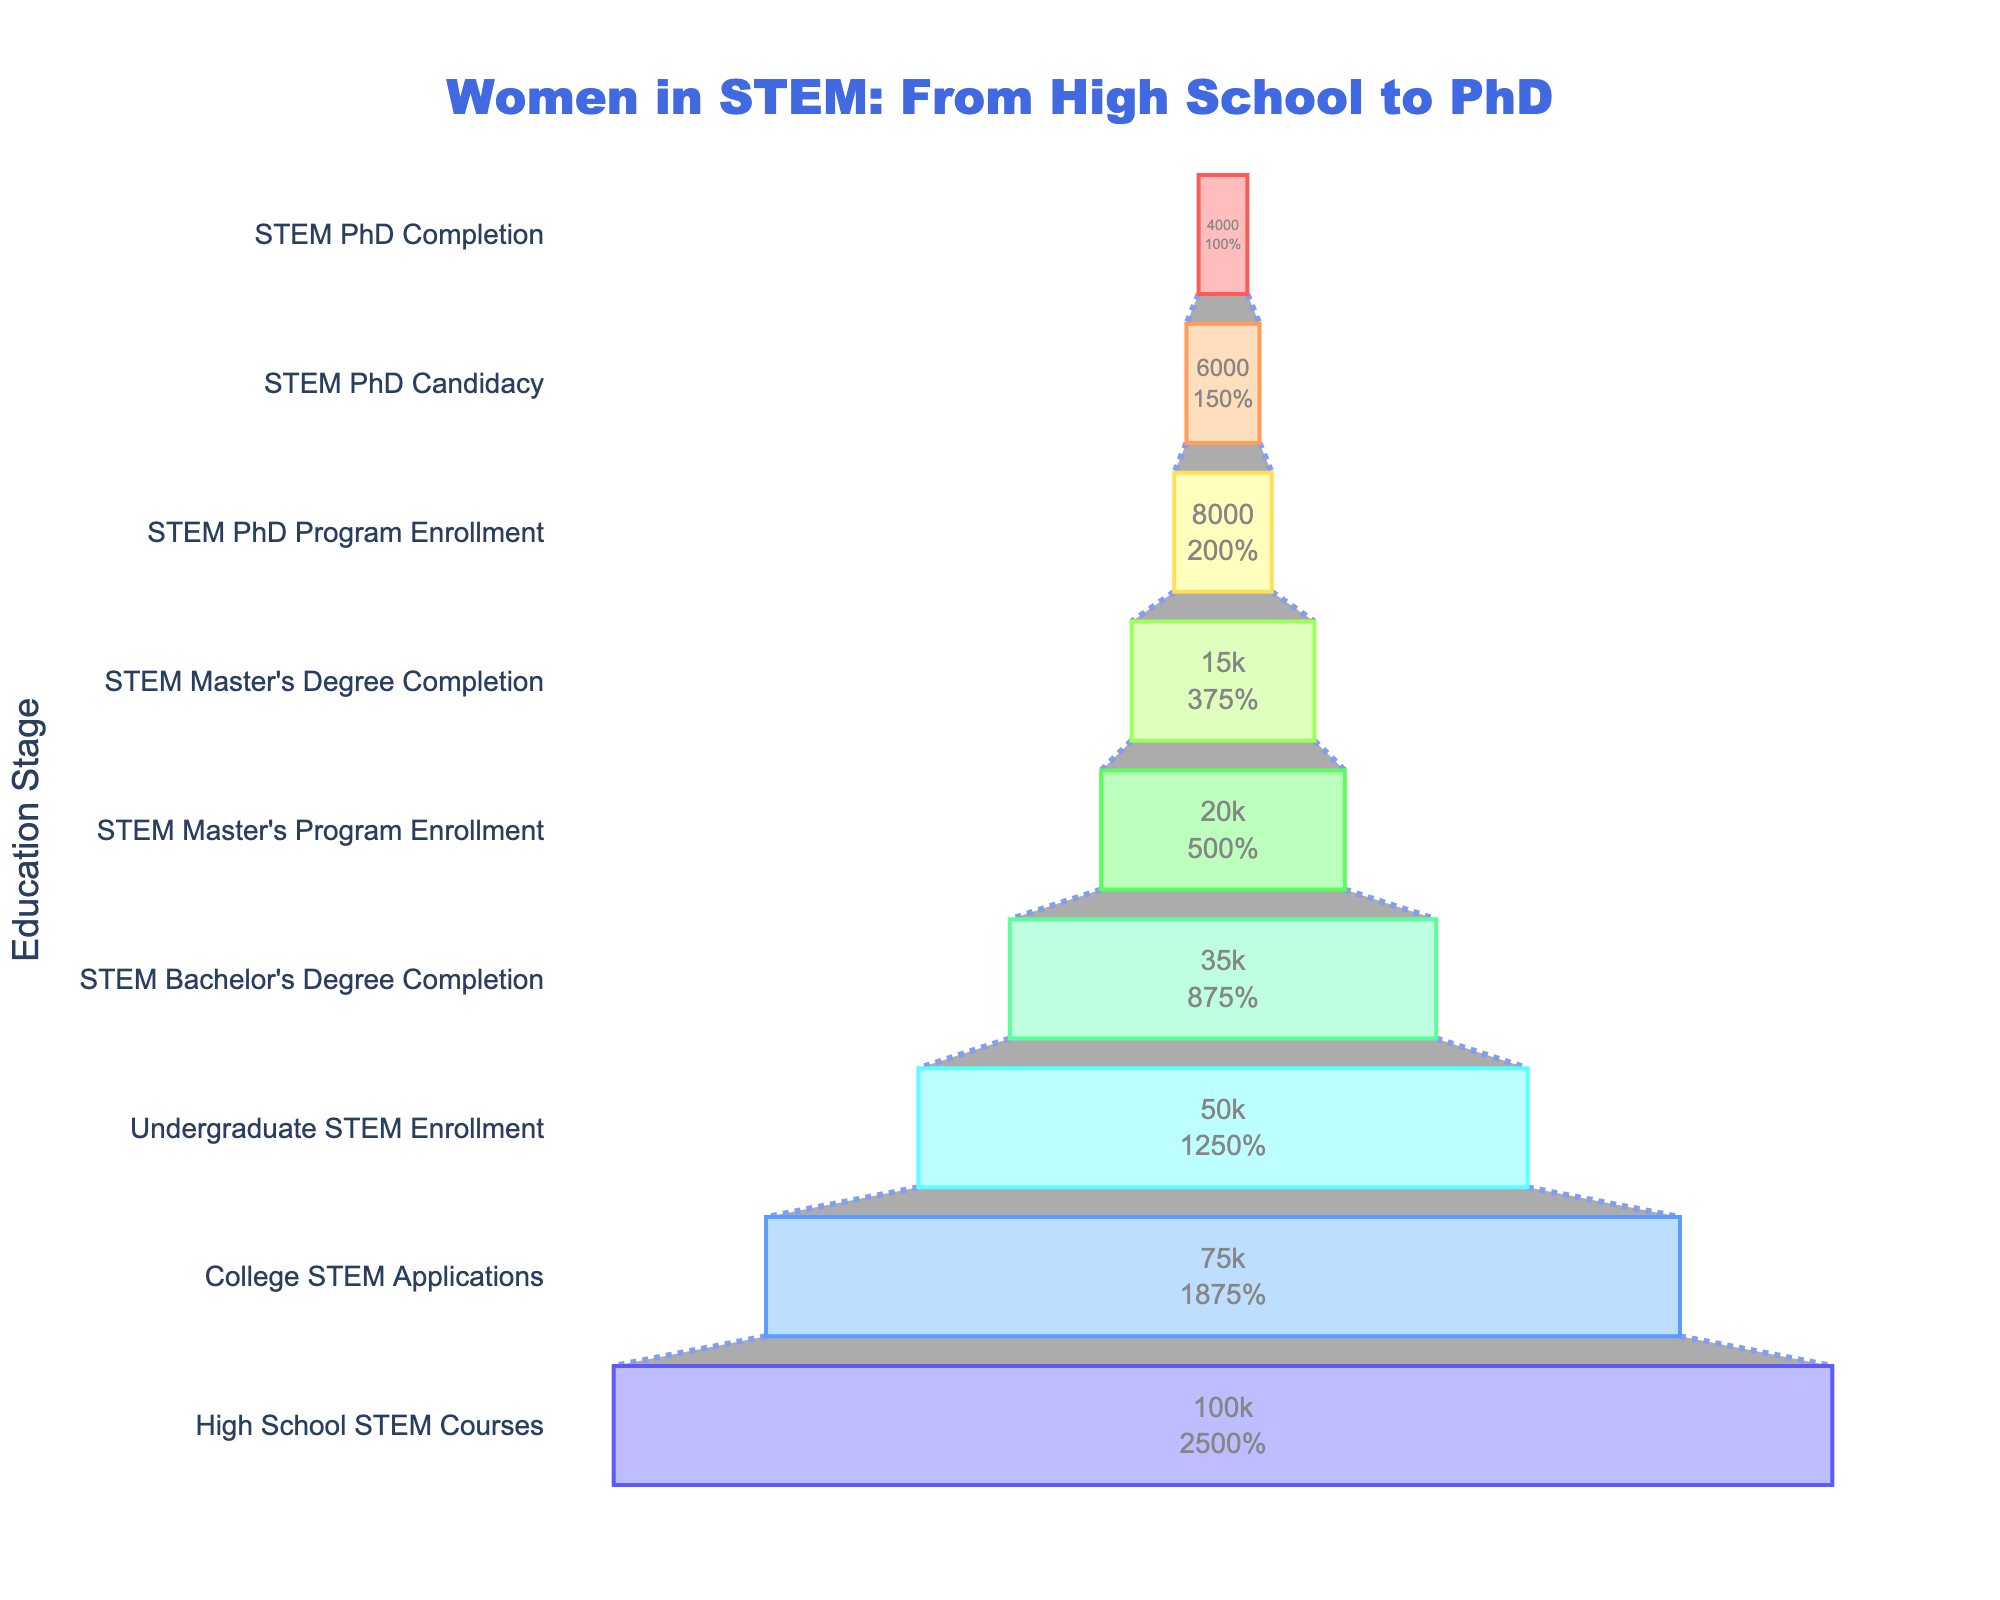What is the title of the funnel chart? The title is located at the top of the funnel chart and is readable directly from the figure.
Answer: Women in STEM: From High School to PhD How many stages are represented in the funnel chart? Count the number of different stages listed on the left side of the funnel chart.
Answer: 9 What is the number of women who completed a STEM Bachelor's Degree? Look for the stage labeled "STEM Bachelor's Degree Completion" and read the corresponding value.
Answer: 35,000 By what percentage do the number of women decrease from 'High School STEM Courses' to 'College STEM Applications'? Calculate the percentage decrease: ((100,000 - 75,000) / 100,000) * 100.
Answer: 25% Compare the number of women who enroll in STEM Master's Programs to those who complete STEM Master's Degrees. Which stage has more women, and by how much? Find the corresponding values for 'STEM Master's Program Enrollment' and 'STEM Master's Degree Completion' and subtract the latter from the former: 20,000 - 15,000.
Answer: STEM Master's Program Enrollment, 5,000 more What is the combined number of women in STEM PhD Program Enrollment and STEM PhD Candidacy stages? Add the number of women in 'STEM PhD Program Enrollment' and 'STEM PhD Candidacy' stages: 8,000 + 6,000.
Answer: 14,000 What is the percentage reduction in the number of women from STEM Master's Program Enrollment to STEM PhD Program Enrollment? Calculate the percentage reduction: ((20,000 - 8,000) / 20,000) * 100.
Answer: 60% Are there more women in the 'STEM Master's Degree Completion' stage or the 'STEM PhD Program Enrollment' stage? Compare the values of the two stages: 15,000 and 8,000.
Answer: STEM Master's Degree Completion Which stage shows the largest drop in the number of women compared to the previous stage? Evaluate the differences between each stage and identify the largest drop: (75,000 - 50,000) is 25,000, which is the largest drop between 'College STEM Applications' and 'Undergraduate STEM Enrollment'.
Answer: College STEM Applications to Undergraduate STEM Enrollment 